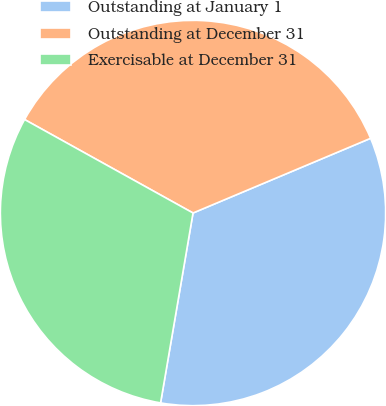<chart> <loc_0><loc_0><loc_500><loc_500><pie_chart><fcel>Outstanding at January 1<fcel>Outstanding at December 31<fcel>Exercisable at December 31<nl><fcel>34.03%<fcel>35.6%<fcel>30.37%<nl></chart> 